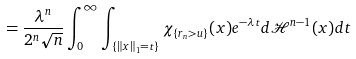<formula> <loc_0><loc_0><loc_500><loc_500>= \frac { \lambda ^ { n } } { 2 ^ { n } \sqrt { n } } \int _ { 0 } ^ { \infty } \int _ { \{ \| x \| _ { 1 } = t \} } \chi _ { \{ r _ { n } > u \} } ( x ) e ^ { - \lambda t } d \mathcal { H } ^ { n - 1 } ( x ) d t</formula> 